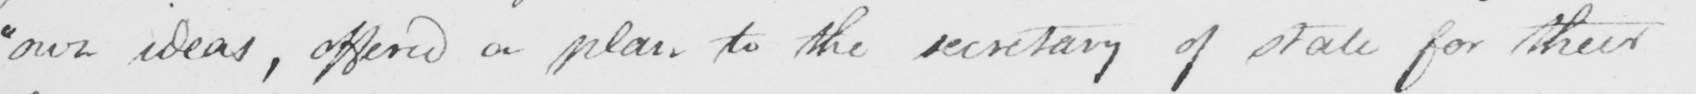What does this handwritten line say? " own ideas , offered a plan to the secretary of state for their 